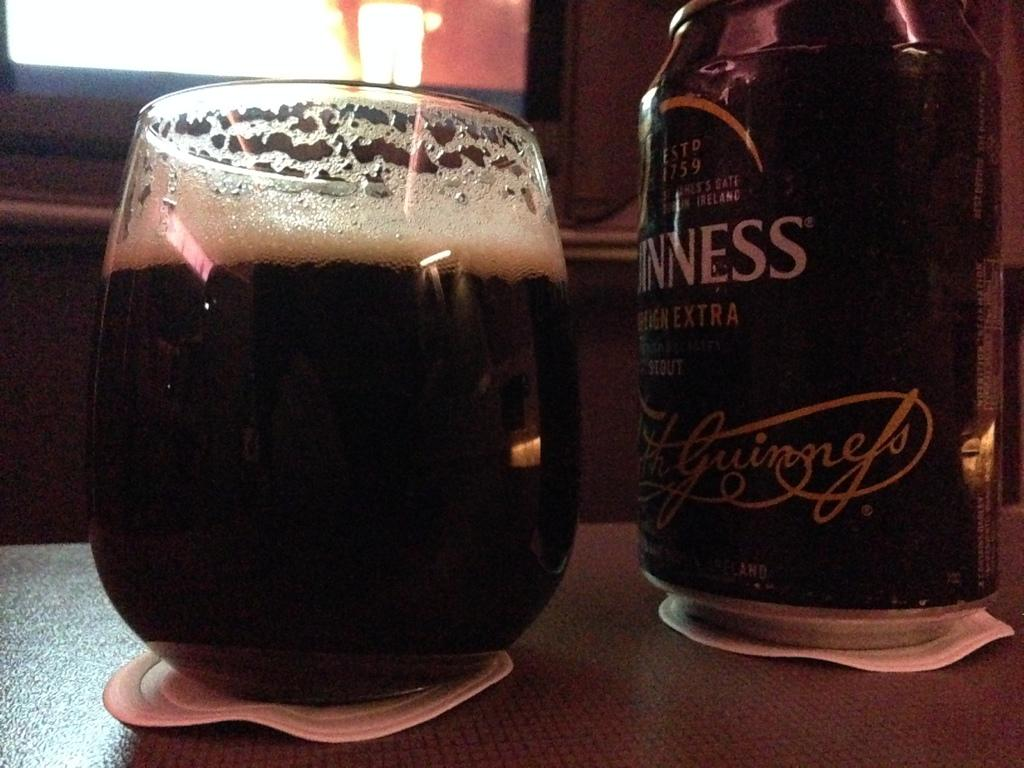<image>
Offer a succinct explanation of the picture presented. A glass of Guinness has been poured from the can into the cup 